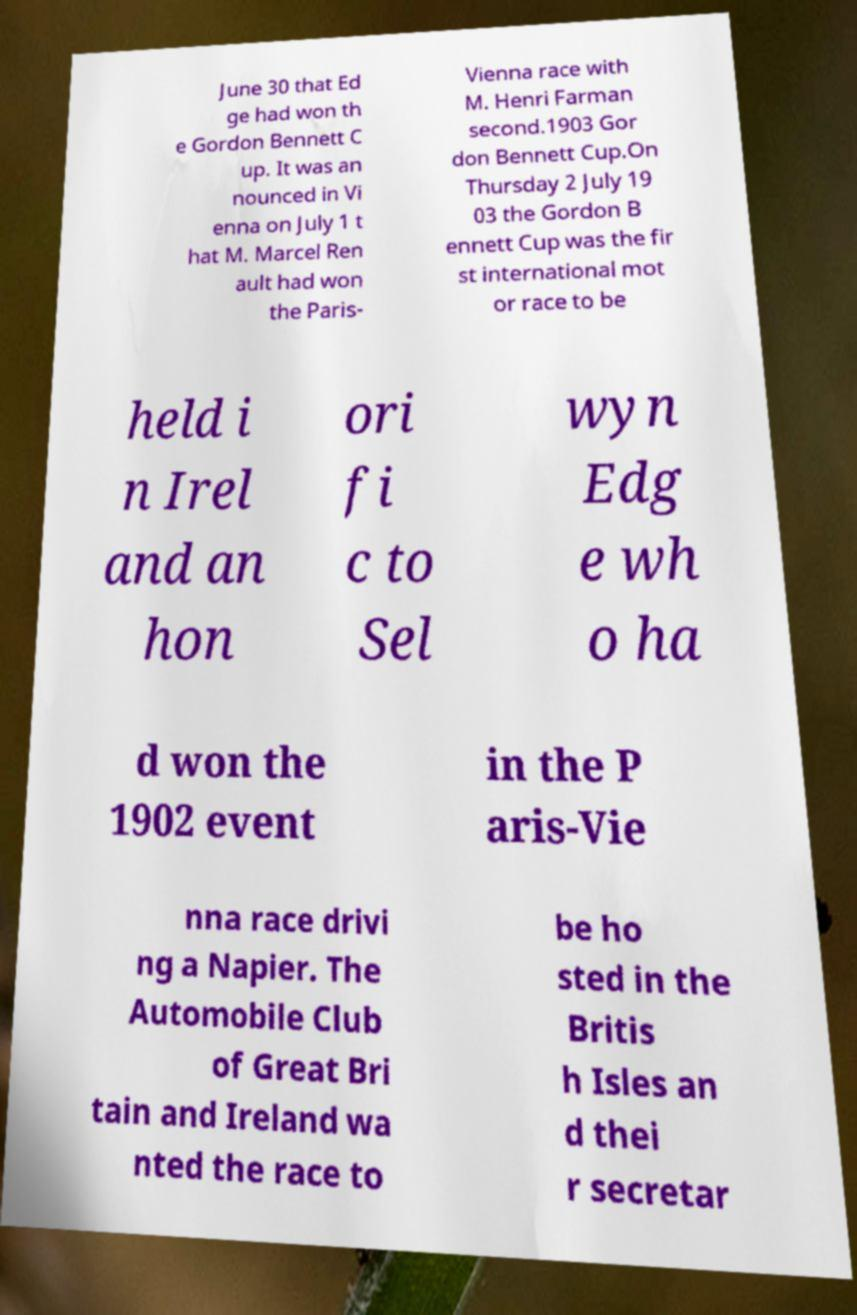Could you assist in decoding the text presented in this image and type it out clearly? June 30 that Ed ge had won th e Gordon Bennett C up. It was an nounced in Vi enna on July 1 t hat M. Marcel Ren ault had won the Paris- Vienna race with M. Henri Farman second.1903 Gor don Bennett Cup.On Thursday 2 July 19 03 the Gordon B ennett Cup was the fir st international mot or race to be held i n Irel and an hon ori fi c to Sel wyn Edg e wh o ha d won the 1902 event in the P aris-Vie nna race drivi ng a Napier. The Automobile Club of Great Bri tain and Ireland wa nted the race to be ho sted in the Britis h Isles an d thei r secretar 